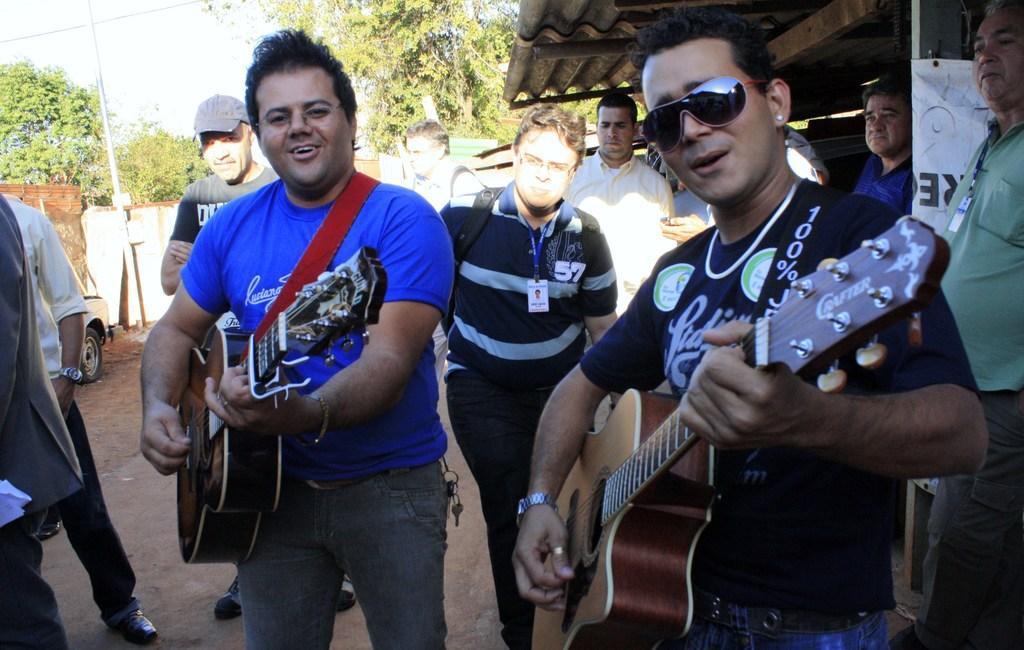Could you give a brief overview of what you see in this image? The picture consists of two men playing guitar in the front and in the back side there are few men walking. 